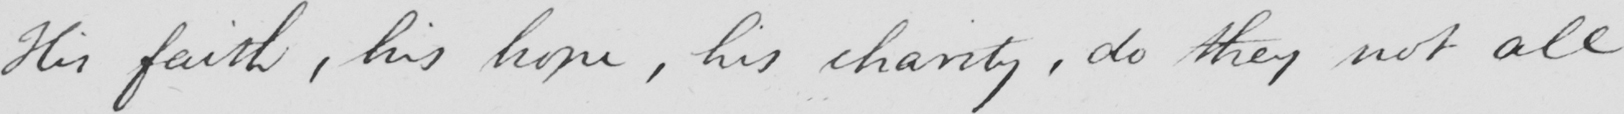Please transcribe the handwritten text in this image. This faith, his hope, his charity, do they not all 